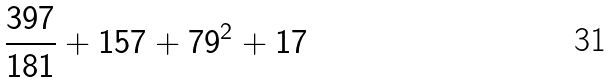Convert formula to latex. <formula><loc_0><loc_0><loc_500><loc_500>\frac { 3 9 7 } { 1 8 1 } + 1 5 7 + 7 9 ^ { 2 } + 1 7</formula> 